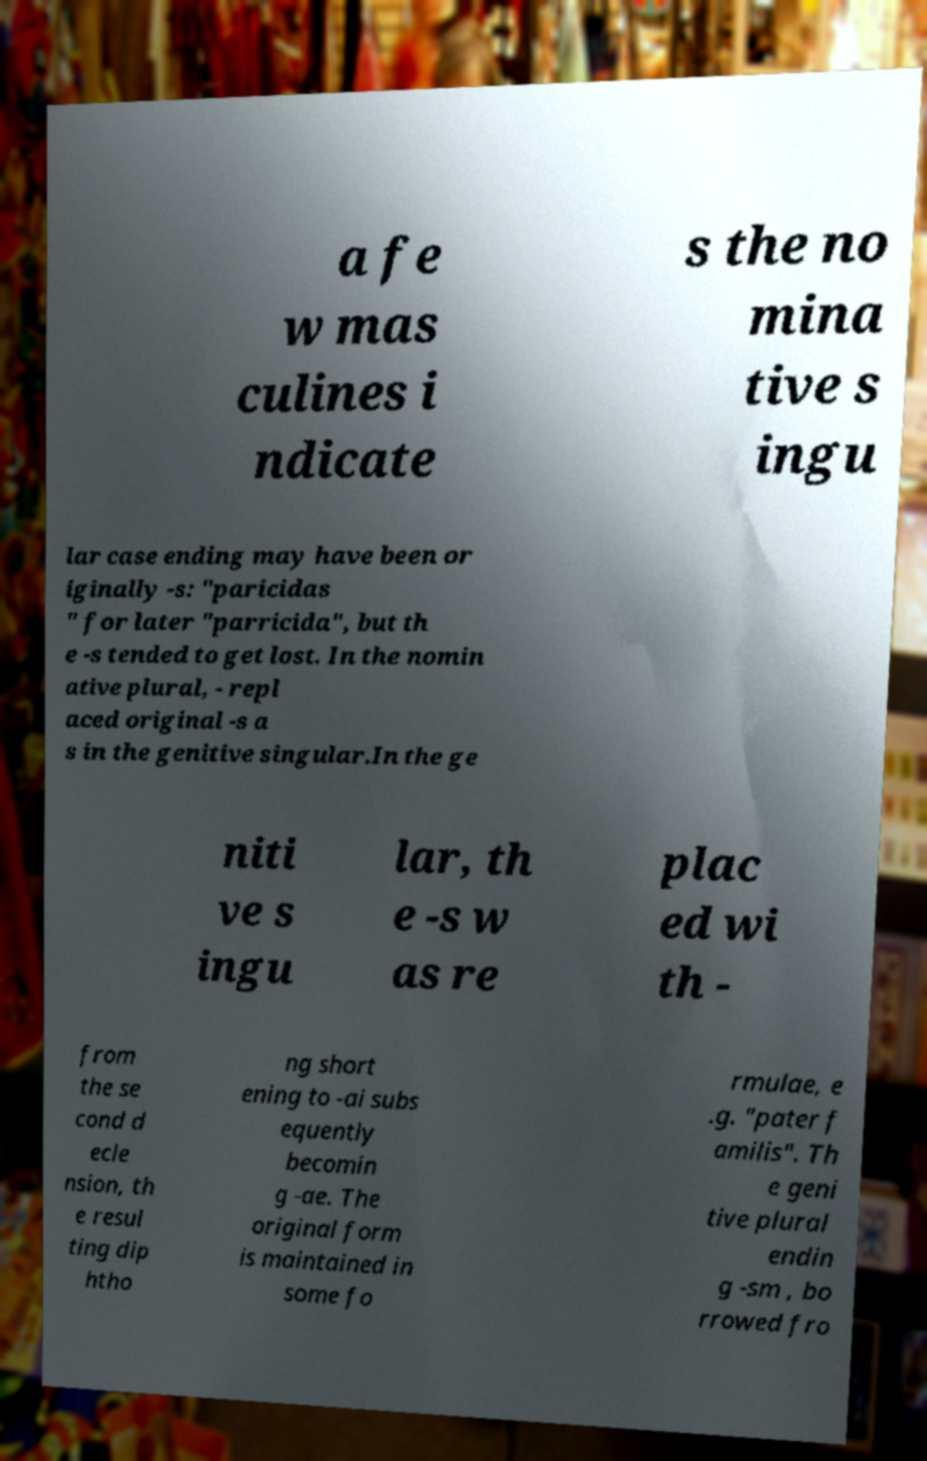For documentation purposes, I need the text within this image transcribed. Could you provide that? a fe w mas culines i ndicate s the no mina tive s ingu lar case ending may have been or iginally -s: "paricidas " for later "parricida", but th e -s tended to get lost. In the nomin ative plural, - repl aced original -s a s in the genitive singular.In the ge niti ve s ingu lar, th e -s w as re plac ed wi th - from the se cond d ecle nsion, th e resul ting dip htho ng short ening to -ai subs equently becomin g -ae. The original form is maintained in some fo rmulae, e .g. "pater f amilis". Th e geni tive plural endin g -sm , bo rrowed fro 